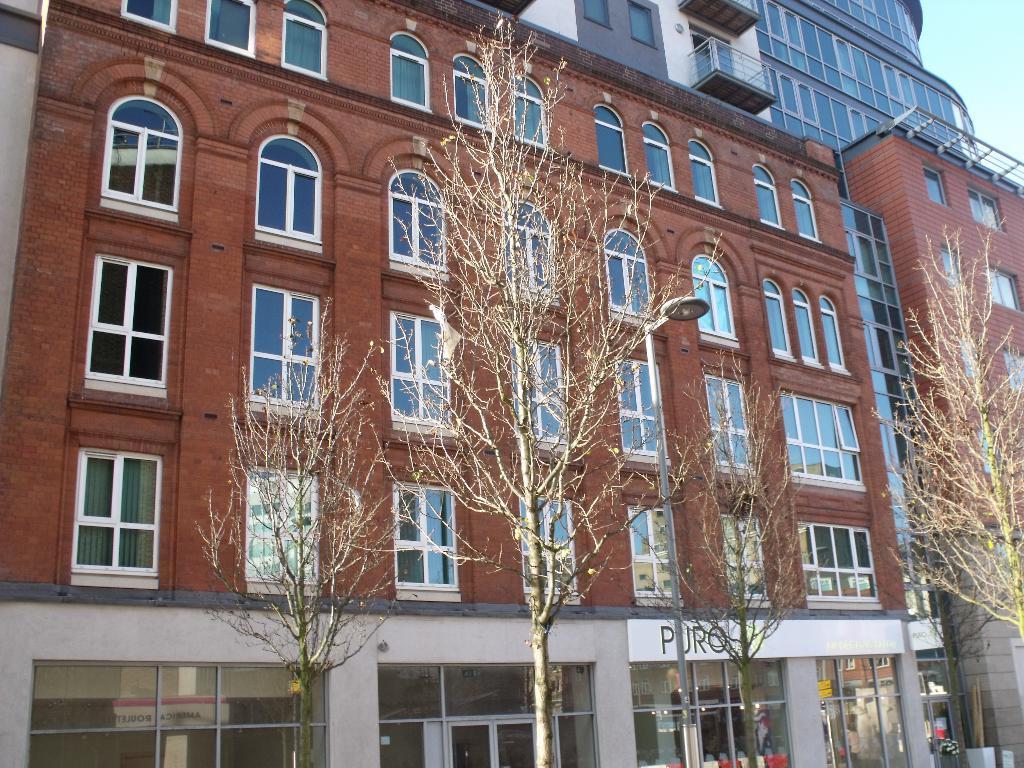Describe this image in one or two sentences. In this picture there are buildings in the center of the image and there are trees in front of the buildings. 